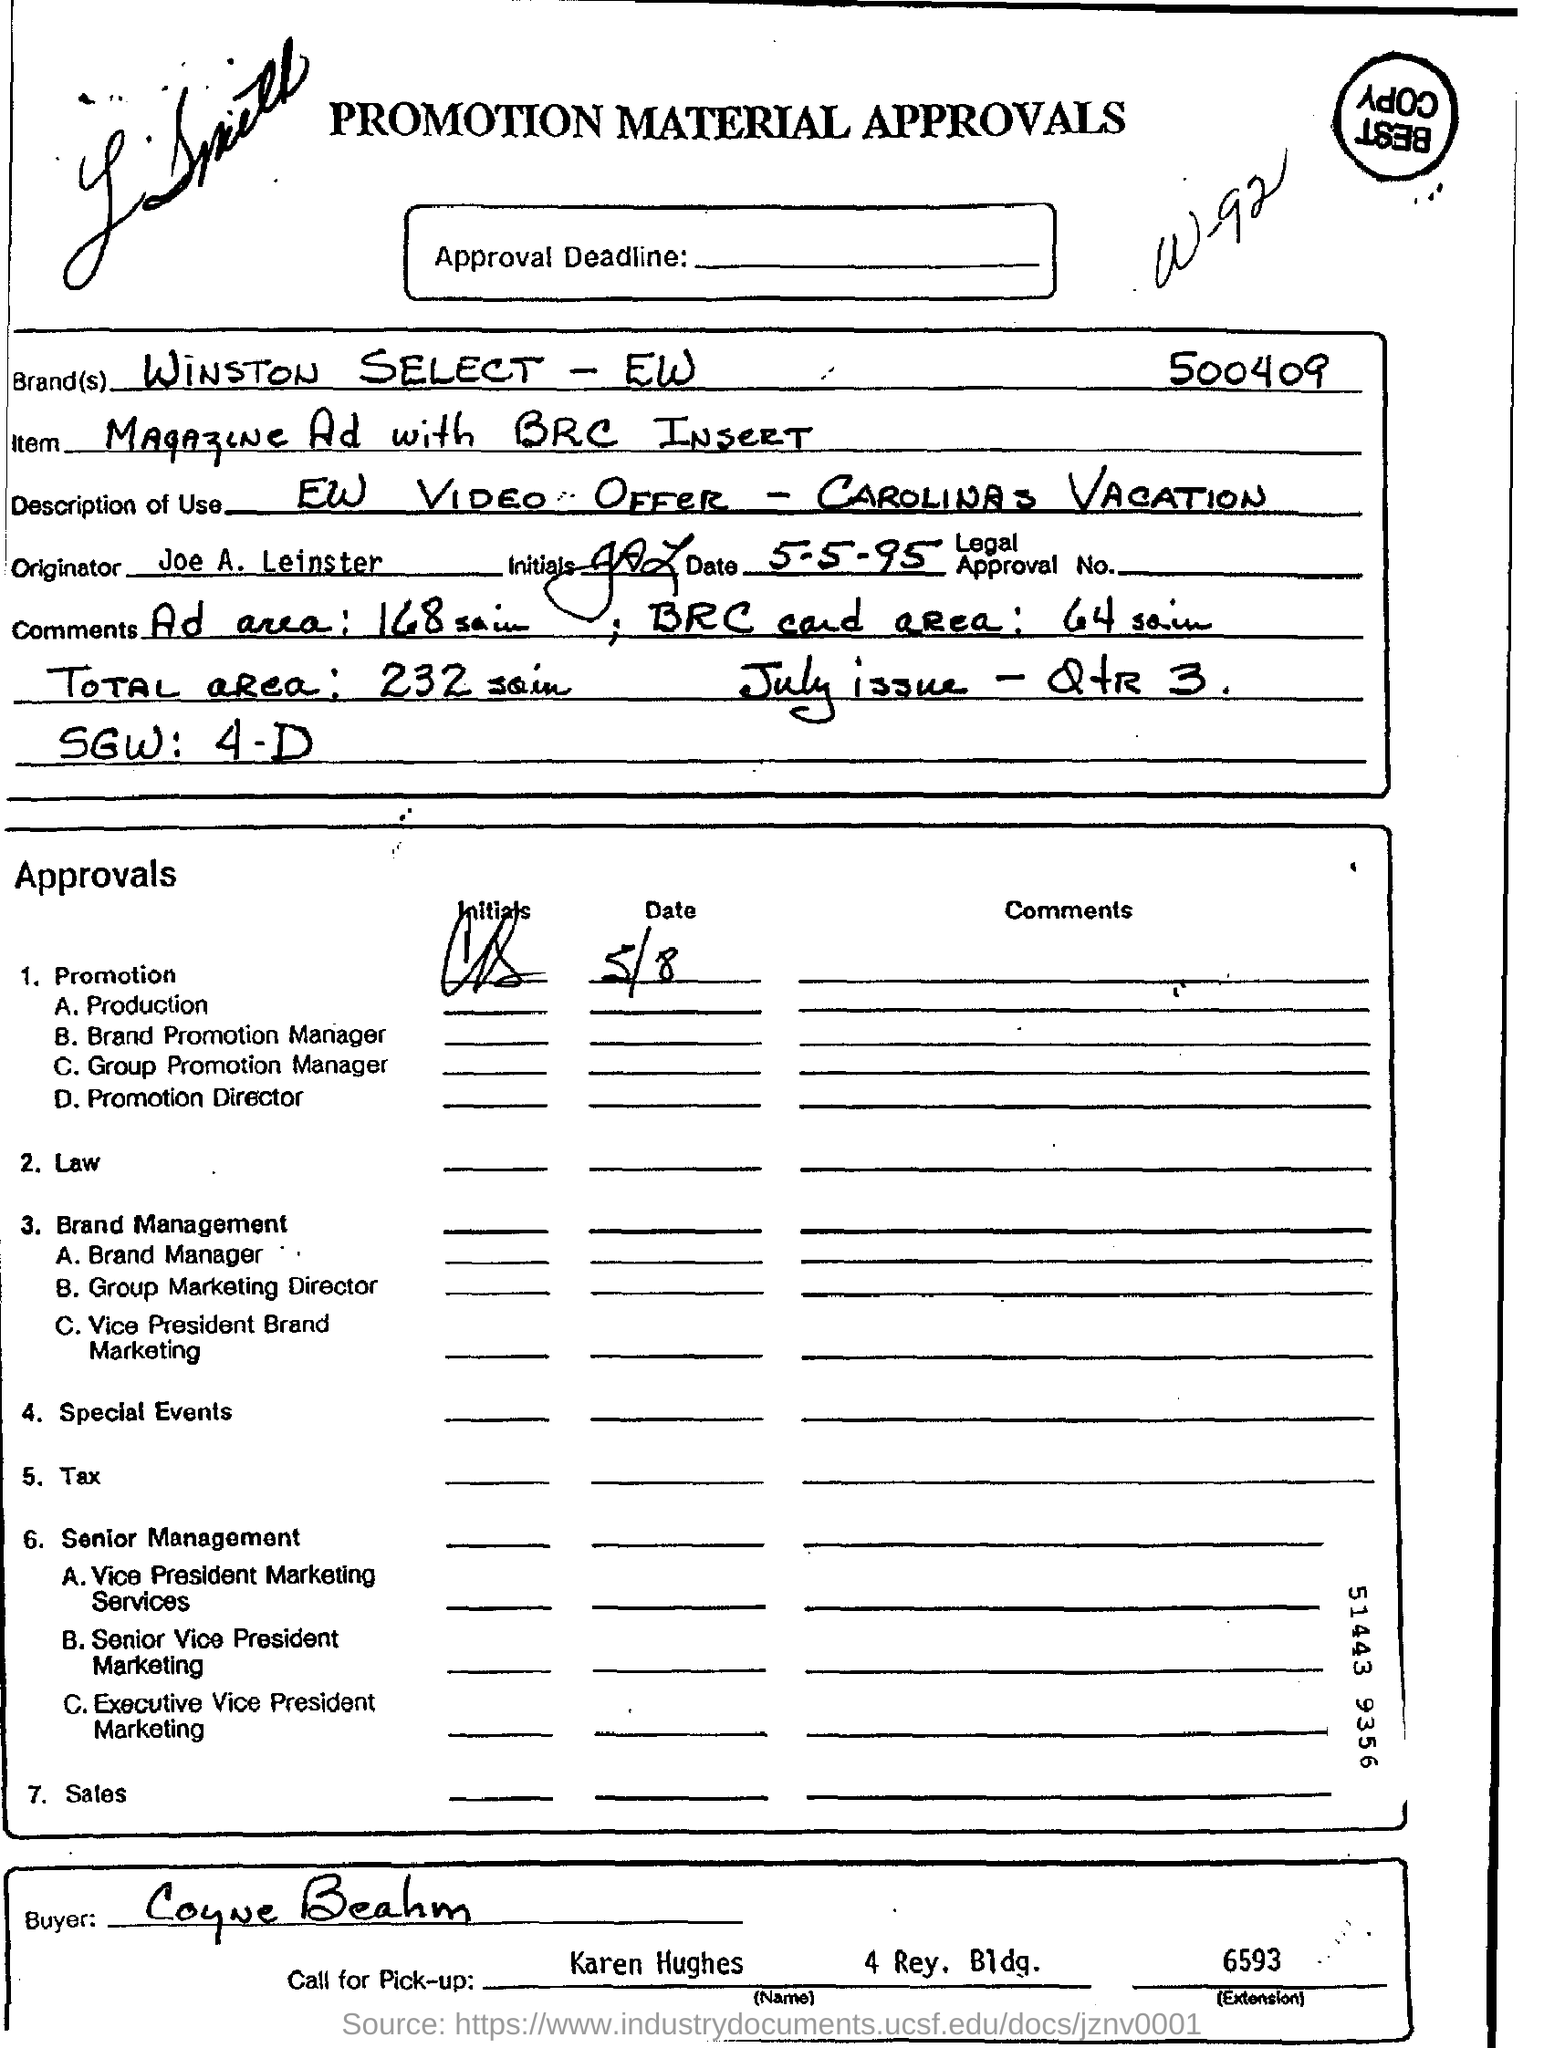Which brand is mentioned in the form?
Keep it short and to the point. Winston select - ew                             500409. What is the item description?
Provide a short and direct response. Magazine ad with brc insert. Who is the originator?
Offer a very short reply. Joe a. leinster. For which issue of the magazine is the ad going to be inserted?
Offer a terse response. July issue - QtR 3. What is the "total area"?
Give a very brief answer. 232 sqin. 